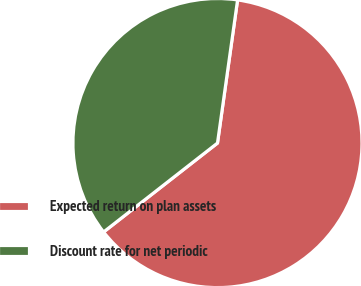<chart> <loc_0><loc_0><loc_500><loc_500><pie_chart><fcel>Expected return on plan assets<fcel>Discount rate for net periodic<nl><fcel>62.23%<fcel>37.77%<nl></chart> 